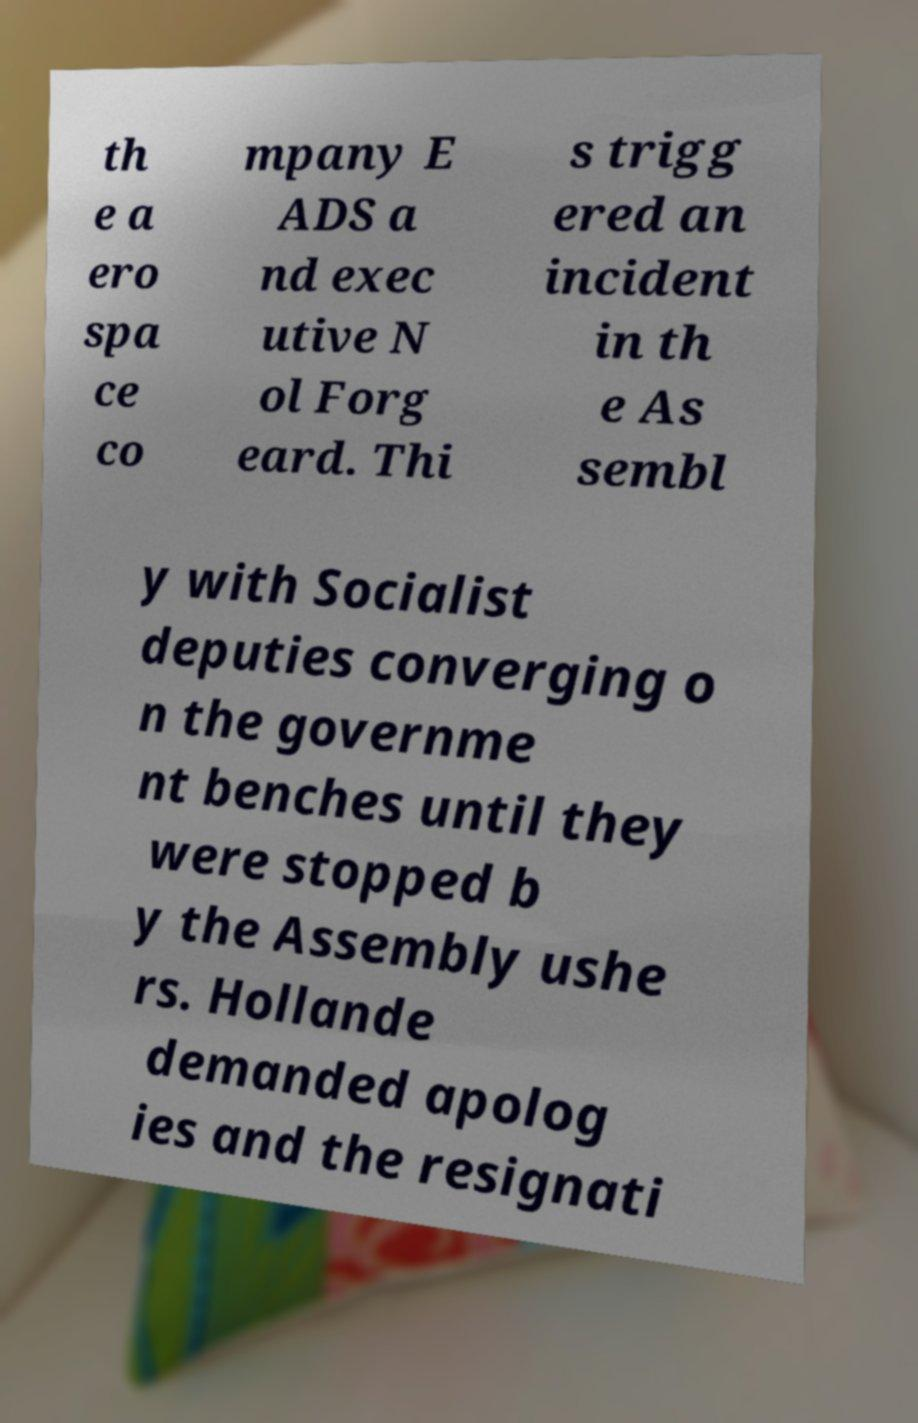Can you accurately transcribe the text from the provided image for me? th e a ero spa ce co mpany E ADS a nd exec utive N ol Forg eard. Thi s trigg ered an incident in th e As sembl y with Socialist deputies converging o n the governme nt benches until they were stopped b y the Assembly ushe rs. Hollande demanded apolog ies and the resignati 